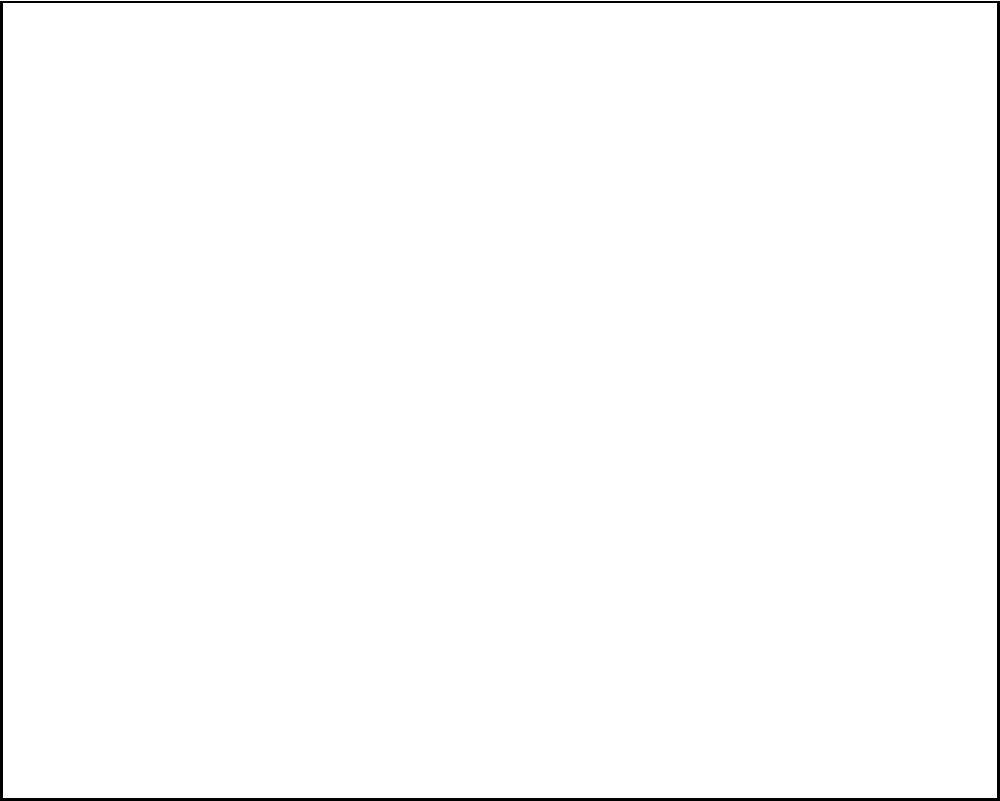In Cedar Hill's first telecommunications office, a vintage telephone switchboard was used to connect calls. Based on the wiring diagram shown, how many individual telephone lines could this switchboard accommodate, and what was the primary method for connecting calls? To answer this question, let's analyze the wiring diagram of the vintage telephone switchboard:

1. Count the number of horizontal lines:
   There are 5 horizontal lines in the diagram, each representing an individual telephone line.

2. Identify the connection method:
   We can see three columns of red dots along each horizontal line. These represent the switchboard jacks.

3. Understand the operator's role:
   The diagram shows an "Operator's Panel" and a "Headset" section, indicating that a human operator was involved in the connection process.

4. Connecting calls:
   The operator would use patch cords to connect different jacks, effectively linking two telephone lines together to establish a call.

5. Switchboard capacity:
   The number of horizontal lines represents the maximum number of individual telephone lines that can be connected simultaneously.

Therefore, this switchboard could accommodate 5 individual telephone lines, and the primary method for connecting calls was manual patching by a human operator using the switchboard jacks.
Answer: 5 lines; manual patching by operator 